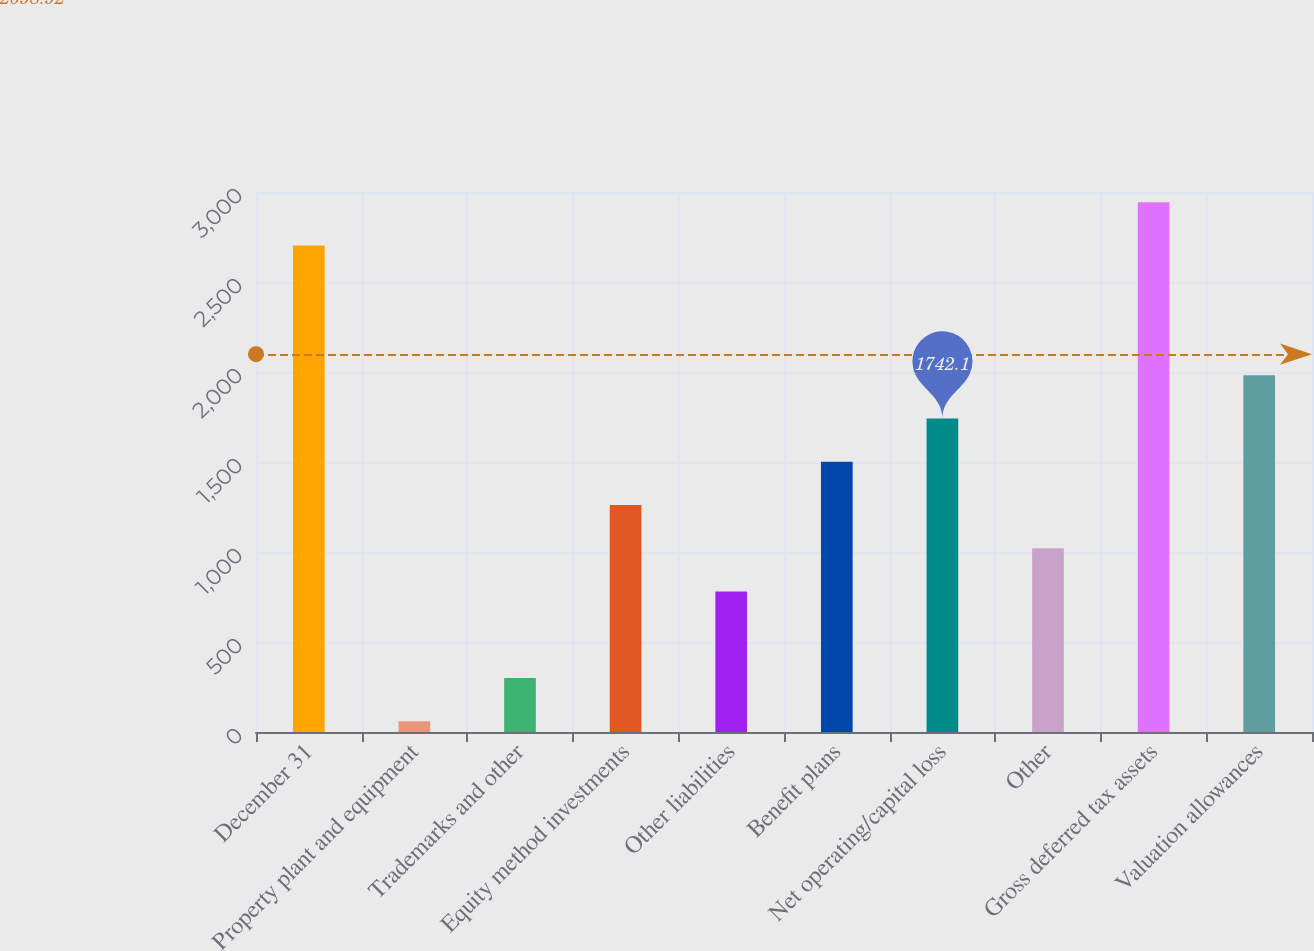Convert chart. <chart><loc_0><loc_0><loc_500><loc_500><bar_chart><fcel>December 31<fcel>Property plant and equipment<fcel>Trademarks and other<fcel>Equity method investments<fcel>Other liabilities<fcel>Benefit plans<fcel>Net operating/capital loss<fcel>Other<fcel>Gross deferred tax assets<fcel>Valuation allowances<nl><fcel>2703.3<fcel>60<fcel>300.3<fcel>1261.5<fcel>780.9<fcel>1501.8<fcel>1742.1<fcel>1021.2<fcel>2943.6<fcel>1982.4<nl></chart> 